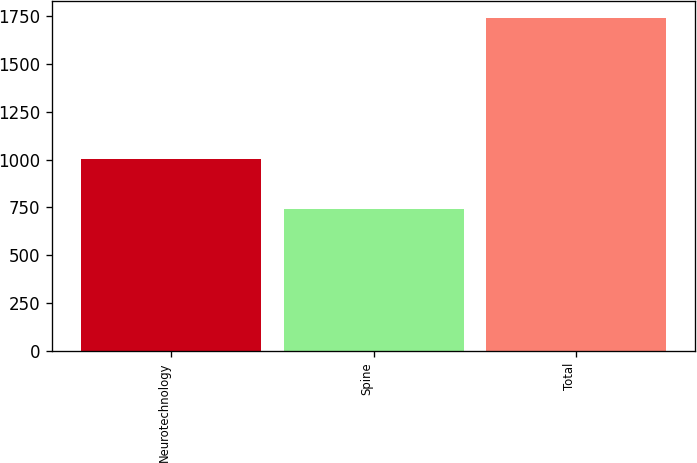Convert chart. <chart><loc_0><loc_0><loc_500><loc_500><bar_chart><fcel>Neurotechnology<fcel>Spine<fcel>Total<nl><fcel>1001<fcel>740<fcel>1741<nl></chart> 